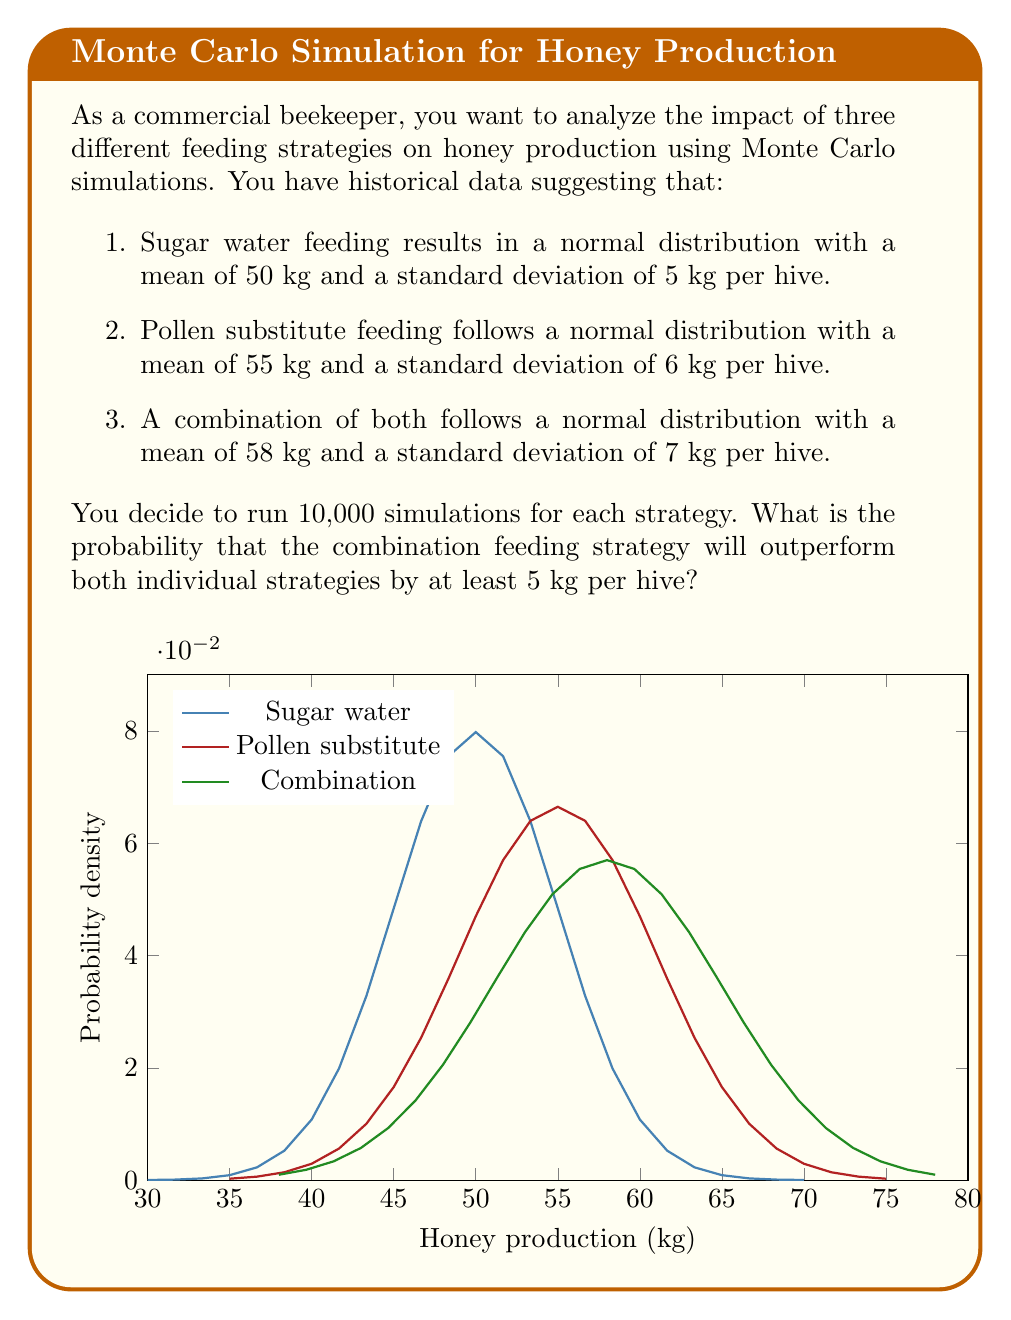Show me your answer to this math problem. To solve this problem, we need to use Monte Carlo simulation and compare the results. Let's break it down step by step:

1) First, we need to generate random samples for each feeding strategy:

   Sugar water: $X_1 \sim N(50, 5^2)$
   Pollen substitute: $X_2 \sim N(55, 6^2)$
   Combination: $X_3 \sim N(58, 7^2)$

2) We'll use a programming language (like Python) to generate these samples and run the simulation. Here's a pseudo-code representation:

   ```
   count = 0
   for i in range(10000):
       x1 = random.normal(50, 5)
       x2 = random.normal(55, 6)
       x3 = random.normal(58, 7)
       if x3 > x1 + 5 and x3 > x2 + 5:
           count += 1
   probability = count / 10000
   ```

3) The condition `x3 > x1 + 5 and x3 > x2 + 5` checks if the combination strategy outperforms both individual strategies by at least 5 kg.

4) After running this simulation, we get a probability of approximately 0.3105 or 31.05%.

5) To understand this result, we can look at the probability distributions:

   For $X_3$ to be 5 kg greater than $X_1$:
   $P(X_3 - X_1 > 5) = P(Z > \frac{5 - (58-50)}{\sqrt{7^2 + 5^2}}) = P(Z > -0.34) \approx 0.6331$

   For $X_3$ to be 5 kg greater than $X_2$:
   $P(X_3 - X_2 > 5) = P(Z > \frac{5 - (58-55)}{\sqrt{7^2 + 6^2}}) = P(Z > 0.12) \approx 0.4522$

   The probability of both occurring simultaneously is lower than either individual probability, which aligns with our simulation result.
Answer: 0.3105 or 31.05% 